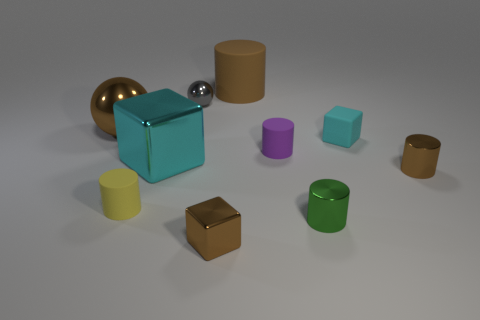Subtract all tiny cyan rubber cubes. How many cubes are left? 2 Subtract all brown blocks. How many blocks are left? 2 Subtract all blocks. How many objects are left? 7 Subtract 3 cylinders. How many cylinders are left? 2 Subtract all gray spheres. Subtract all gray blocks. How many spheres are left? 1 Subtract all yellow cubes. How many brown spheres are left? 1 Subtract all small spheres. Subtract all tiny gray spheres. How many objects are left? 8 Add 1 gray shiny things. How many gray shiny things are left? 2 Add 4 cyan rubber things. How many cyan rubber things exist? 5 Subtract 1 brown balls. How many objects are left? 9 